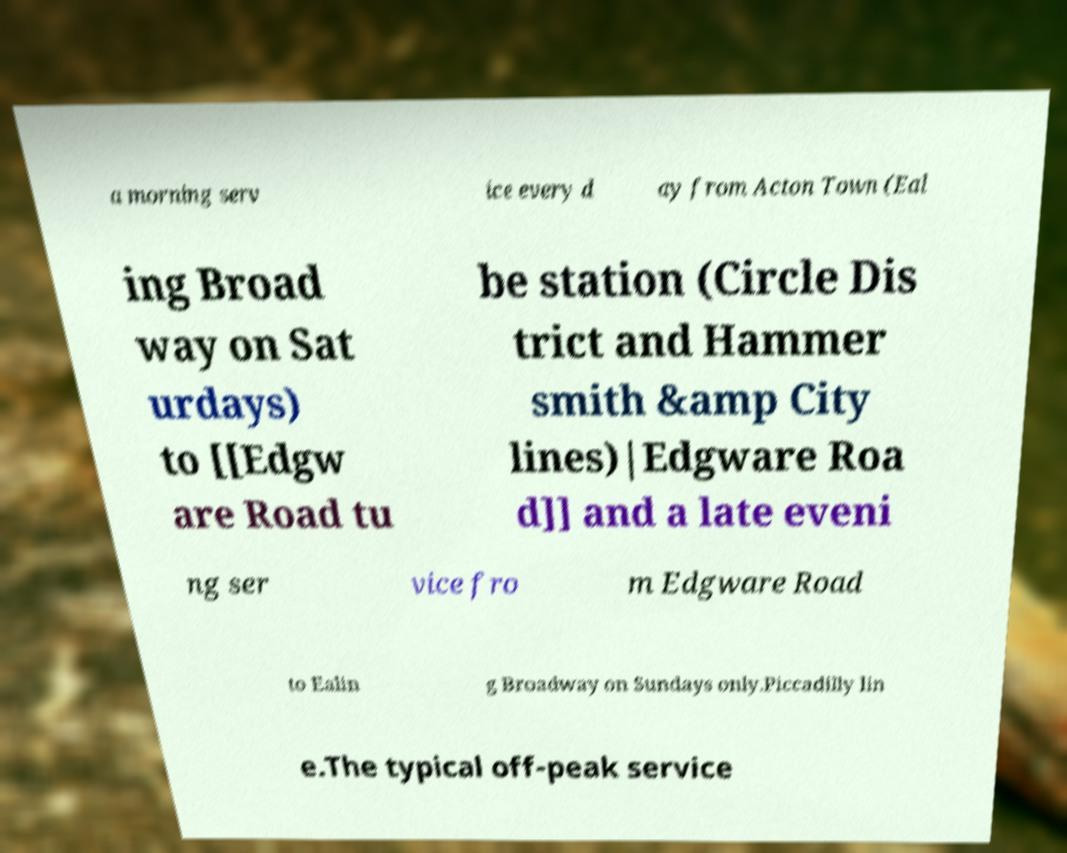Could you assist in decoding the text presented in this image and type it out clearly? a morning serv ice every d ay from Acton Town (Eal ing Broad way on Sat urdays) to [[Edgw are Road tu be station (Circle Dis trict and Hammer smith &amp City lines)|Edgware Roa d]] and a late eveni ng ser vice fro m Edgware Road to Ealin g Broadway on Sundays only.Piccadilly lin e.The typical off-peak service 